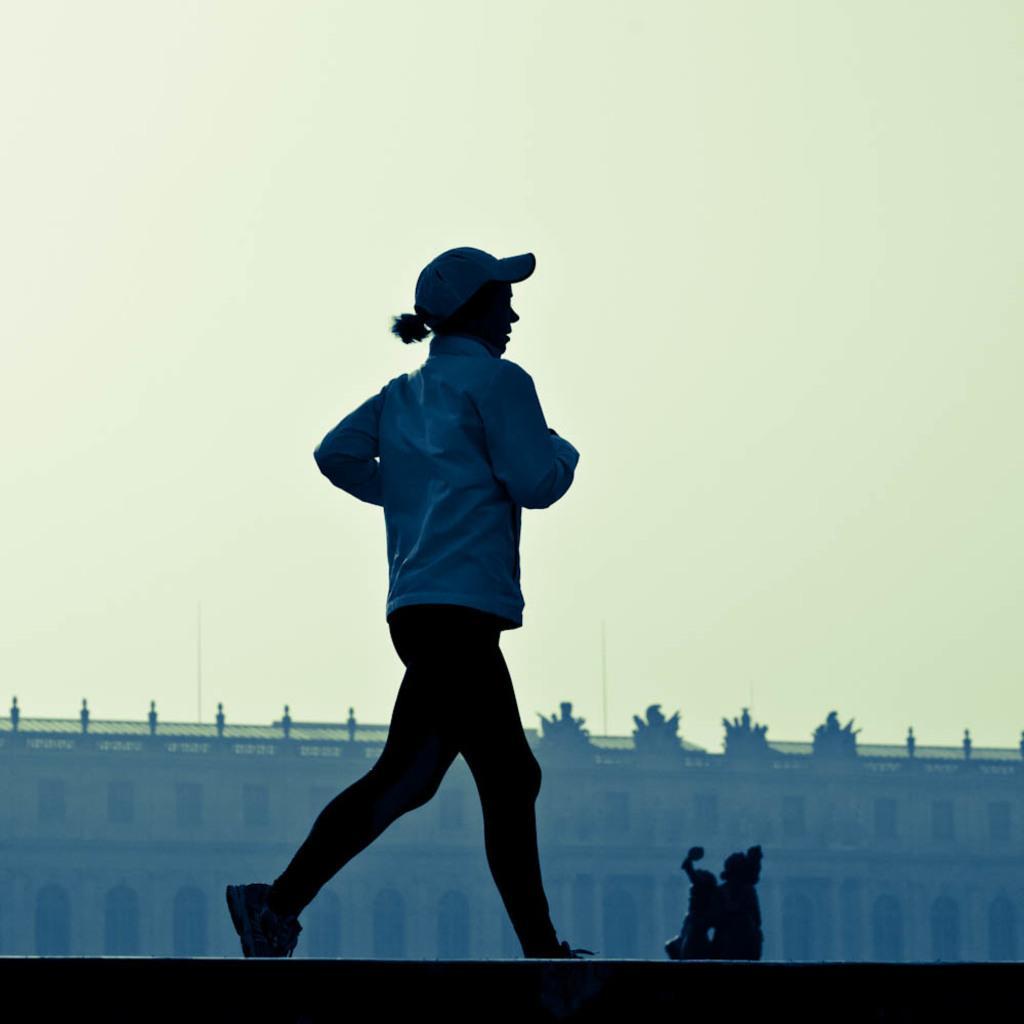Can you describe this image briefly? In this image, I can see the woman running. She wore a jerkin, cap, trouser and shoes. This looks like a wall. I think this is a sculpture. In the background, I can see a building. 